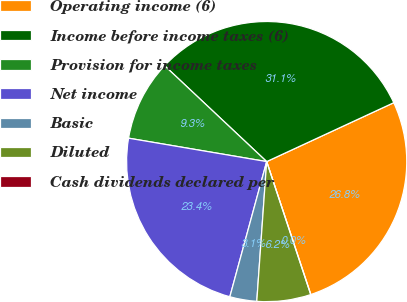Convert chart. <chart><loc_0><loc_0><loc_500><loc_500><pie_chart><fcel>Operating income (6)<fcel>Income before income taxes (6)<fcel>Provision for income taxes<fcel>Net income<fcel>Basic<fcel>Diluted<fcel>Cash dividends declared per<nl><fcel>26.81%<fcel>31.09%<fcel>9.33%<fcel>23.44%<fcel>3.11%<fcel>6.22%<fcel>0.0%<nl></chart> 